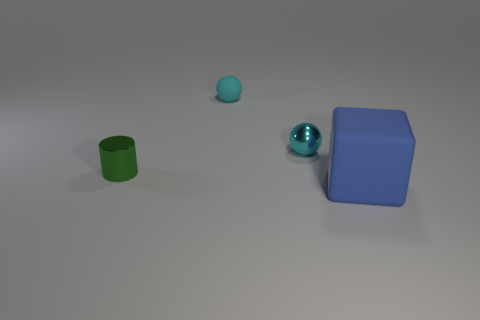What number of other things are the same size as the cyan rubber ball?
Provide a short and direct response. 2. There is a tiny thing that is in front of the metal thing to the right of the green shiny thing that is in front of the cyan metal ball; what shape is it?
Your answer should be very brief. Cylinder. What number of green objects are blocks or cylinders?
Make the answer very short. 1. What number of cyan metallic things are in front of the matte thing in front of the small green shiny cylinder?
Provide a succinct answer. 0. Is there any other thing that has the same color as the rubber block?
Give a very brief answer. No. There is a object that is made of the same material as the block; what shape is it?
Your answer should be compact. Sphere. Is the color of the metal cylinder the same as the block?
Keep it short and to the point. No. Are the ball in front of the cyan matte object and the small cyan ball that is behind the cyan metallic ball made of the same material?
Your answer should be very brief. No. What number of things are red matte cylinders or things on the left side of the large blue thing?
Make the answer very short. 3. Is there anything else that has the same material as the big blue block?
Keep it short and to the point. Yes. 